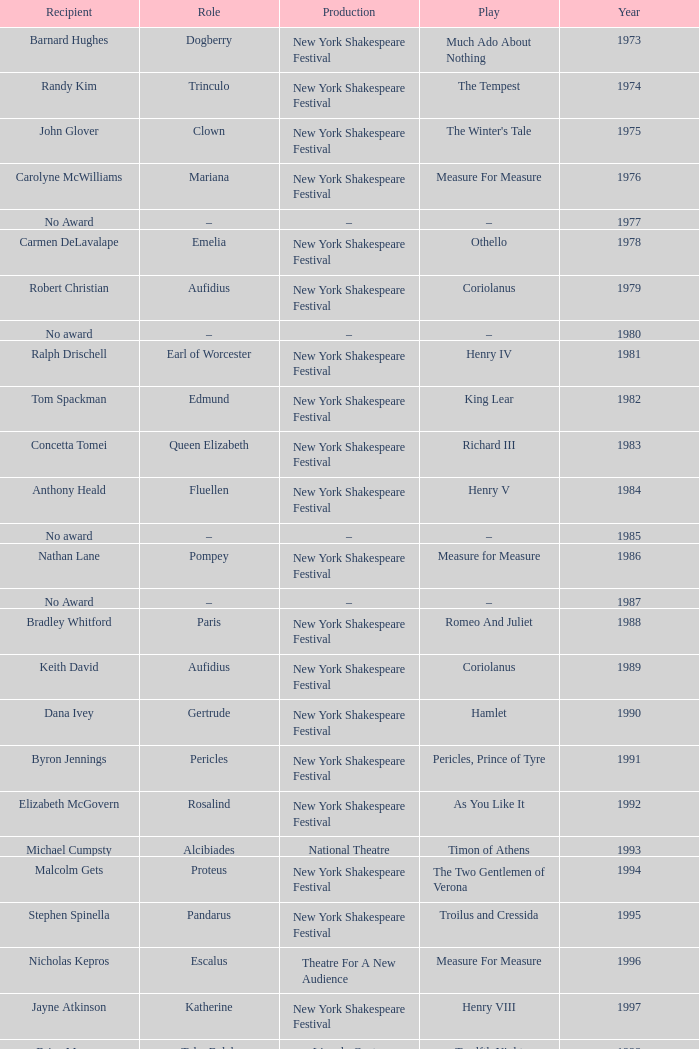Name the play for 1976 Measure For Measure. 